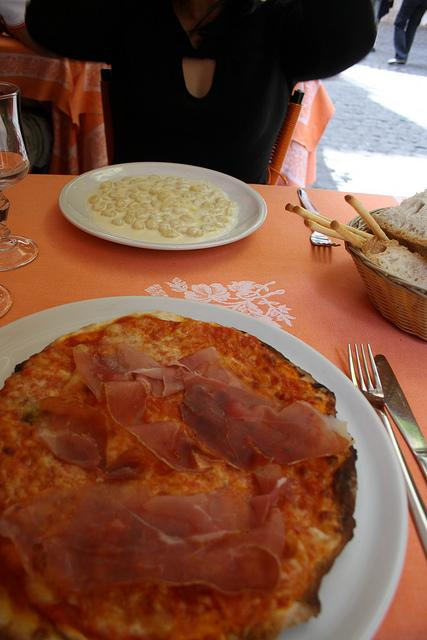What are the sticks seen here made from? Please explain your reasoning. bread. The basket on the table contains breadsticks. 